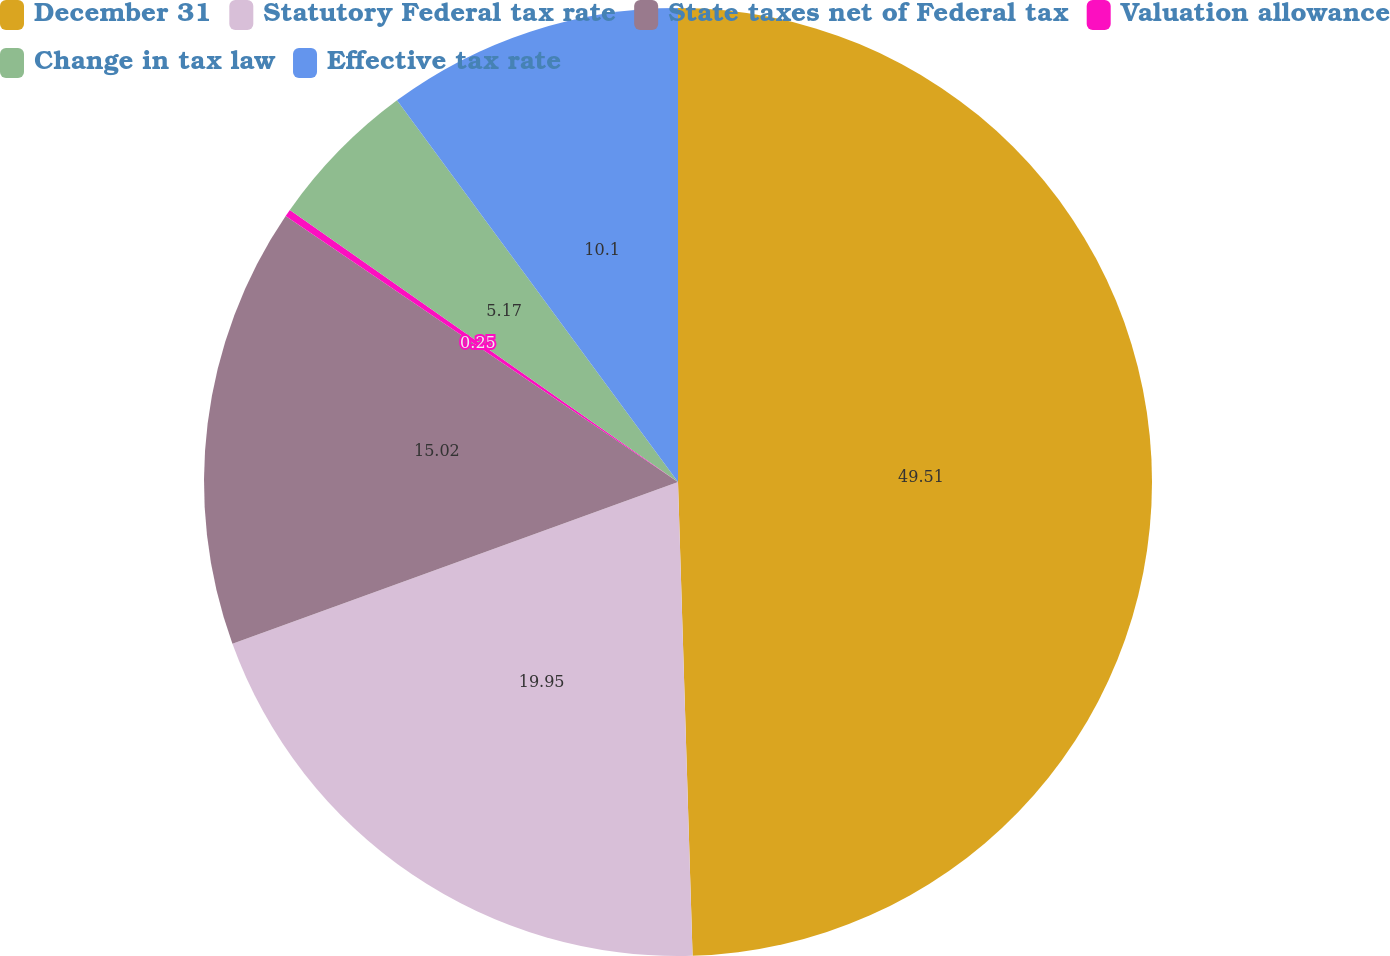Convert chart to OTSL. <chart><loc_0><loc_0><loc_500><loc_500><pie_chart><fcel>December 31<fcel>Statutory Federal tax rate<fcel>State taxes net of Federal tax<fcel>Valuation allowance<fcel>Change in tax law<fcel>Effective tax rate<nl><fcel>49.51%<fcel>19.95%<fcel>15.02%<fcel>0.25%<fcel>5.17%<fcel>10.1%<nl></chart> 